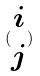Convert formula to latex. <formula><loc_0><loc_0><loc_500><loc_500>( \begin{matrix} i \\ j \end{matrix} )</formula> 